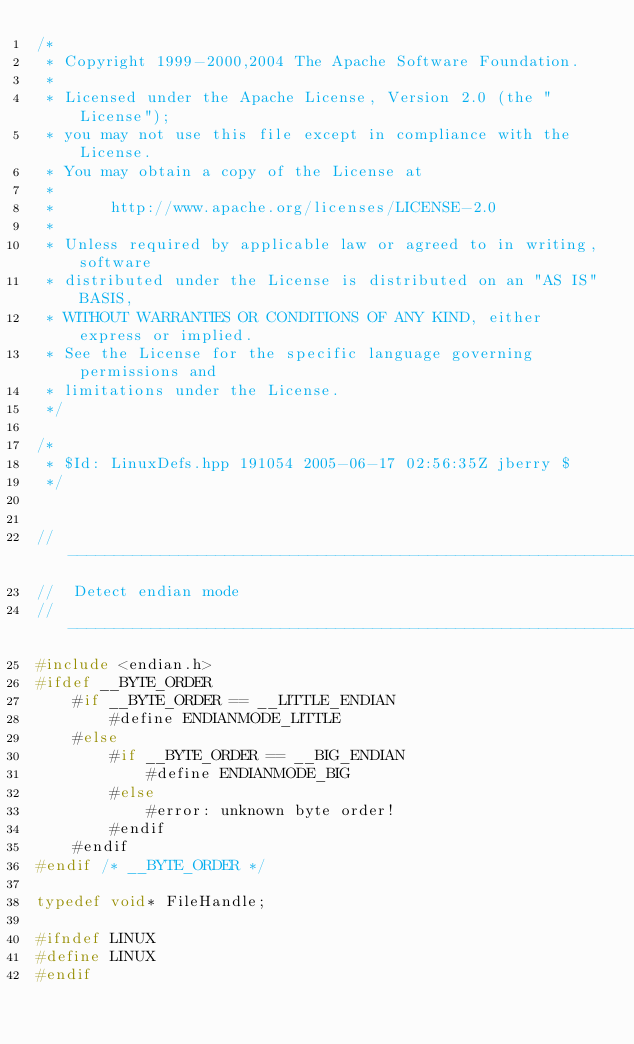Convert code to text. <code><loc_0><loc_0><loc_500><loc_500><_C++_>/*
 * Copyright 1999-2000,2004 The Apache Software Foundation.
 * 
 * Licensed under the Apache License, Version 2.0 (the "License");
 * you may not use this file except in compliance with the License.
 * You may obtain a copy of the License at
 * 
 *      http://www.apache.org/licenses/LICENSE-2.0
 * 
 * Unless required by applicable law or agreed to in writing, software
 * distributed under the License is distributed on an "AS IS" BASIS,
 * WITHOUT WARRANTIES OR CONDITIONS OF ANY KIND, either express or implied.
 * See the License for the specific language governing permissions and
 * limitations under the License.
 */

/*
 * $Id: LinuxDefs.hpp 191054 2005-06-17 02:56:35Z jberry $
 */


// ---------------------------------------------------------------------------
//  Detect endian mode
// ---------------------------------------------------------------------------
#include <endian.h>
#ifdef __BYTE_ORDER
    #if __BYTE_ORDER == __LITTLE_ENDIAN
        #define ENDIANMODE_LITTLE
    #else
        #if __BYTE_ORDER == __BIG_ENDIAN
            #define ENDIANMODE_BIG
        #else
            #error: unknown byte order!
        #endif
    #endif
#endif /* __BYTE_ORDER */

typedef void* FileHandle;

#ifndef LINUX
#define LINUX
#endif
</code> 